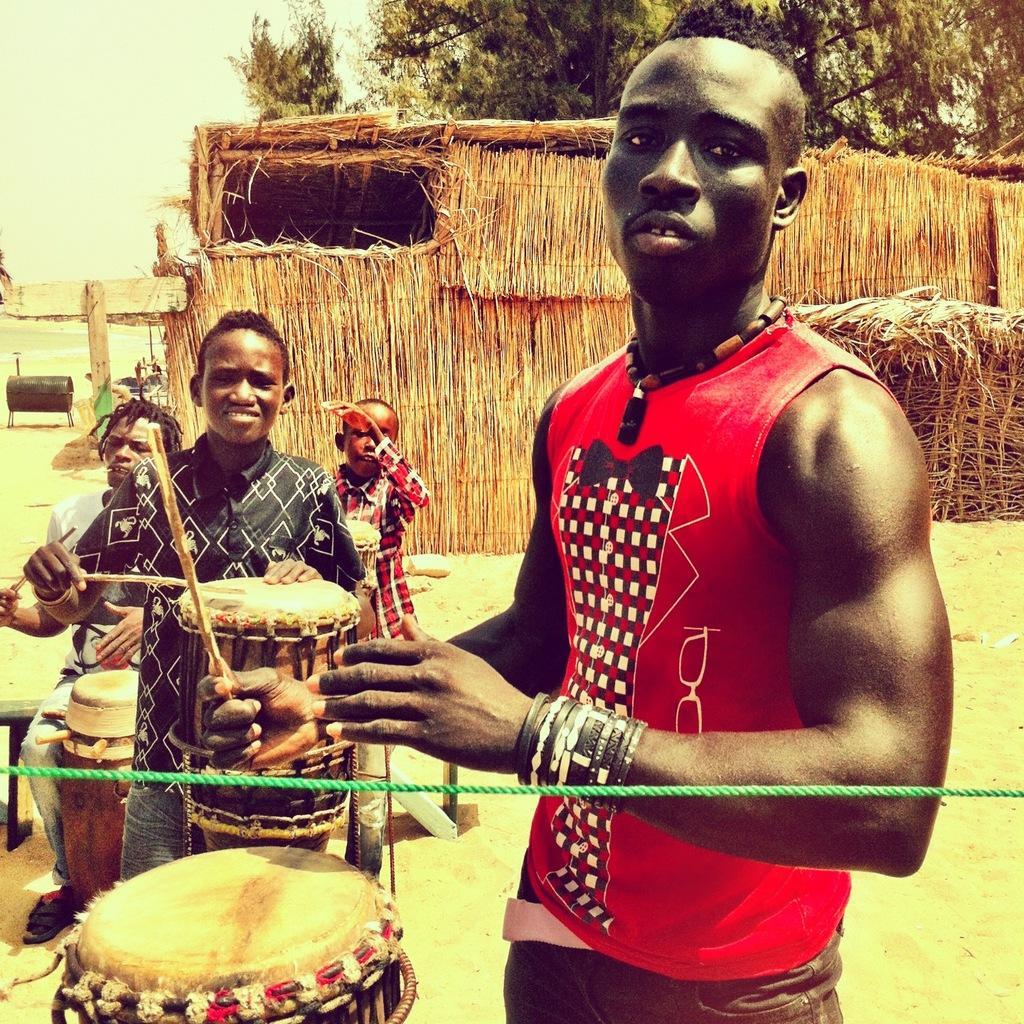Please provide a concise description of this image. In the picture we can see a man standing and playing the drums and beside him we can see three boys are also playing the drums and behind them, we can see a hut with dried grass and behind it, we can see a tree and beside it we can see a part of the railing and the sky. 